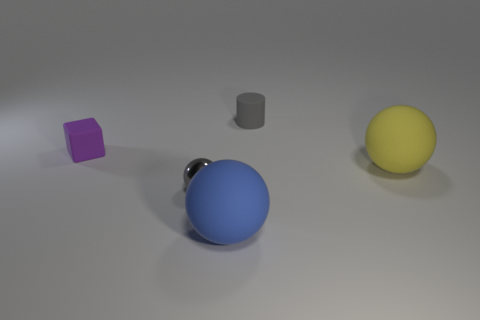Add 1 small shiny objects. How many objects exist? 6 Subtract all spheres. How many objects are left? 2 Add 2 purple cubes. How many purple cubes are left? 3 Add 1 big cylinders. How many big cylinders exist? 1 Subtract 1 yellow balls. How many objects are left? 4 Subtract all big brown metallic blocks. Subtract all yellow matte spheres. How many objects are left? 4 